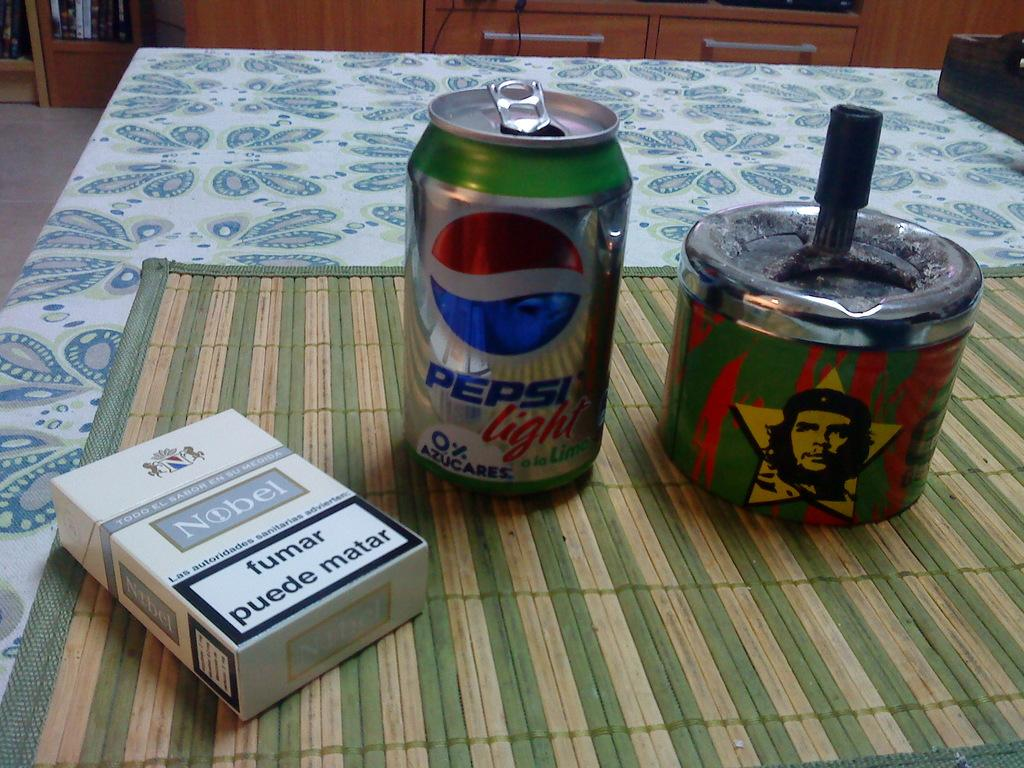<image>
Present a compact description of the photo's key features. A can of Pepsi light sits on a striped placemat along with some cigarettes. 